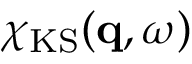<formula> <loc_0><loc_0><loc_500><loc_500>\chi _ { K S } ( q , \omega )</formula> 